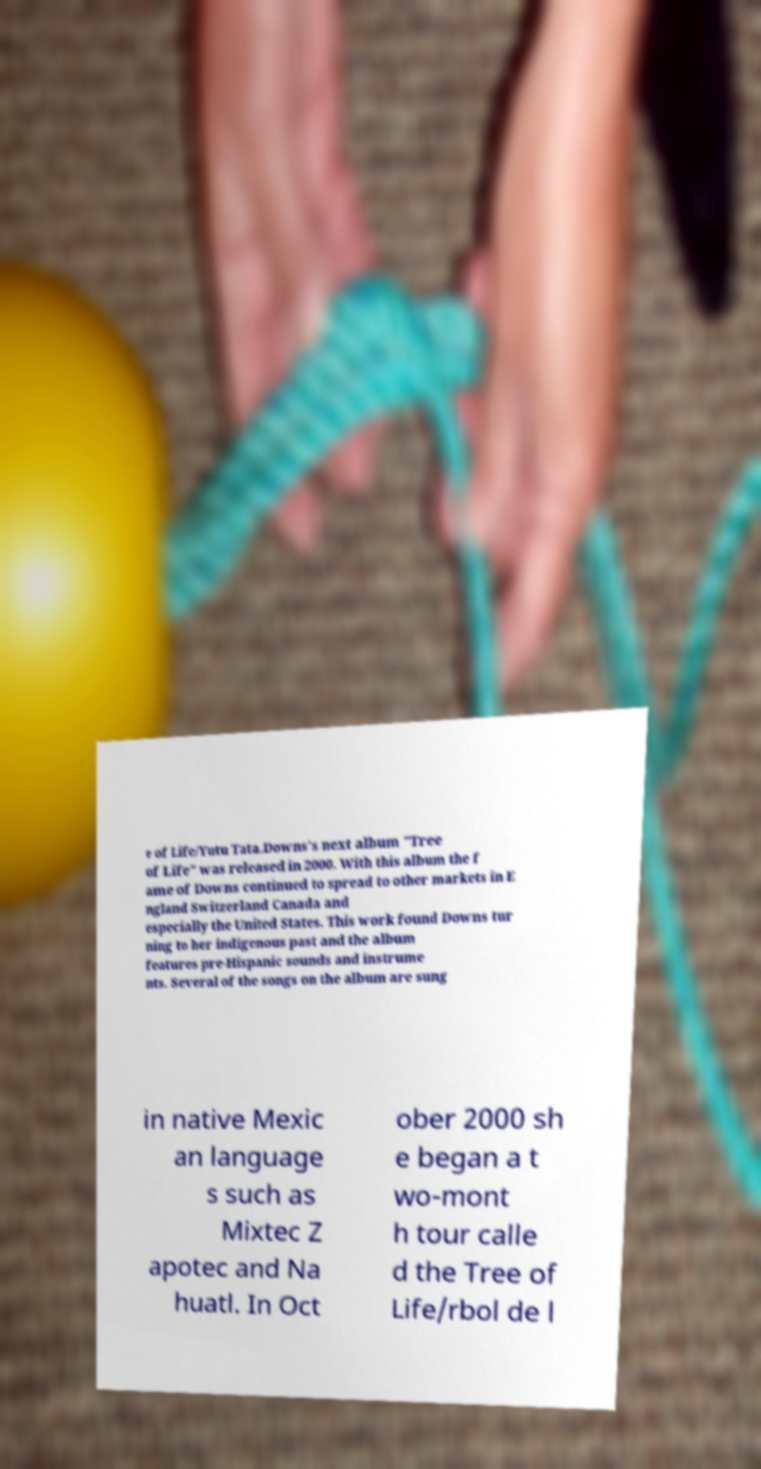Can you read and provide the text displayed in the image?This photo seems to have some interesting text. Can you extract and type it out for me? e of Life/Yutu Tata.Downs's next album "Tree of Life" was released in 2000. With this album the f ame of Downs continued to spread to other markets in E ngland Switzerland Canada and especially the United States. This work found Downs tur ning to her indigenous past and the album features pre-Hispanic sounds and instrume nts. Several of the songs on the album are sung in native Mexic an language s such as Mixtec Z apotec and Na huatl. In Oct ober 2000 sh e began a t wo-mont h tour calle d the Tree of Life/rbol de l 